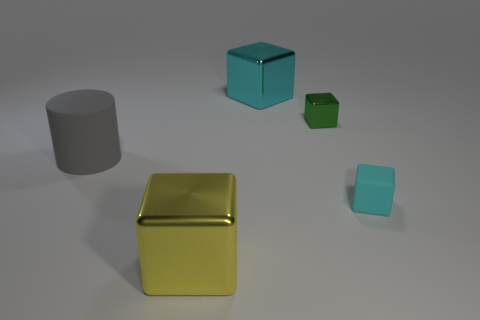What materials do the objects seem to be made of? The objects in the image appear to be made of a metal-like material, given their luster and reflections. Are they all the same color? No, the objects have different colors. There is a gold cube, a blue cube, a green cube, and a gray cylinder. 